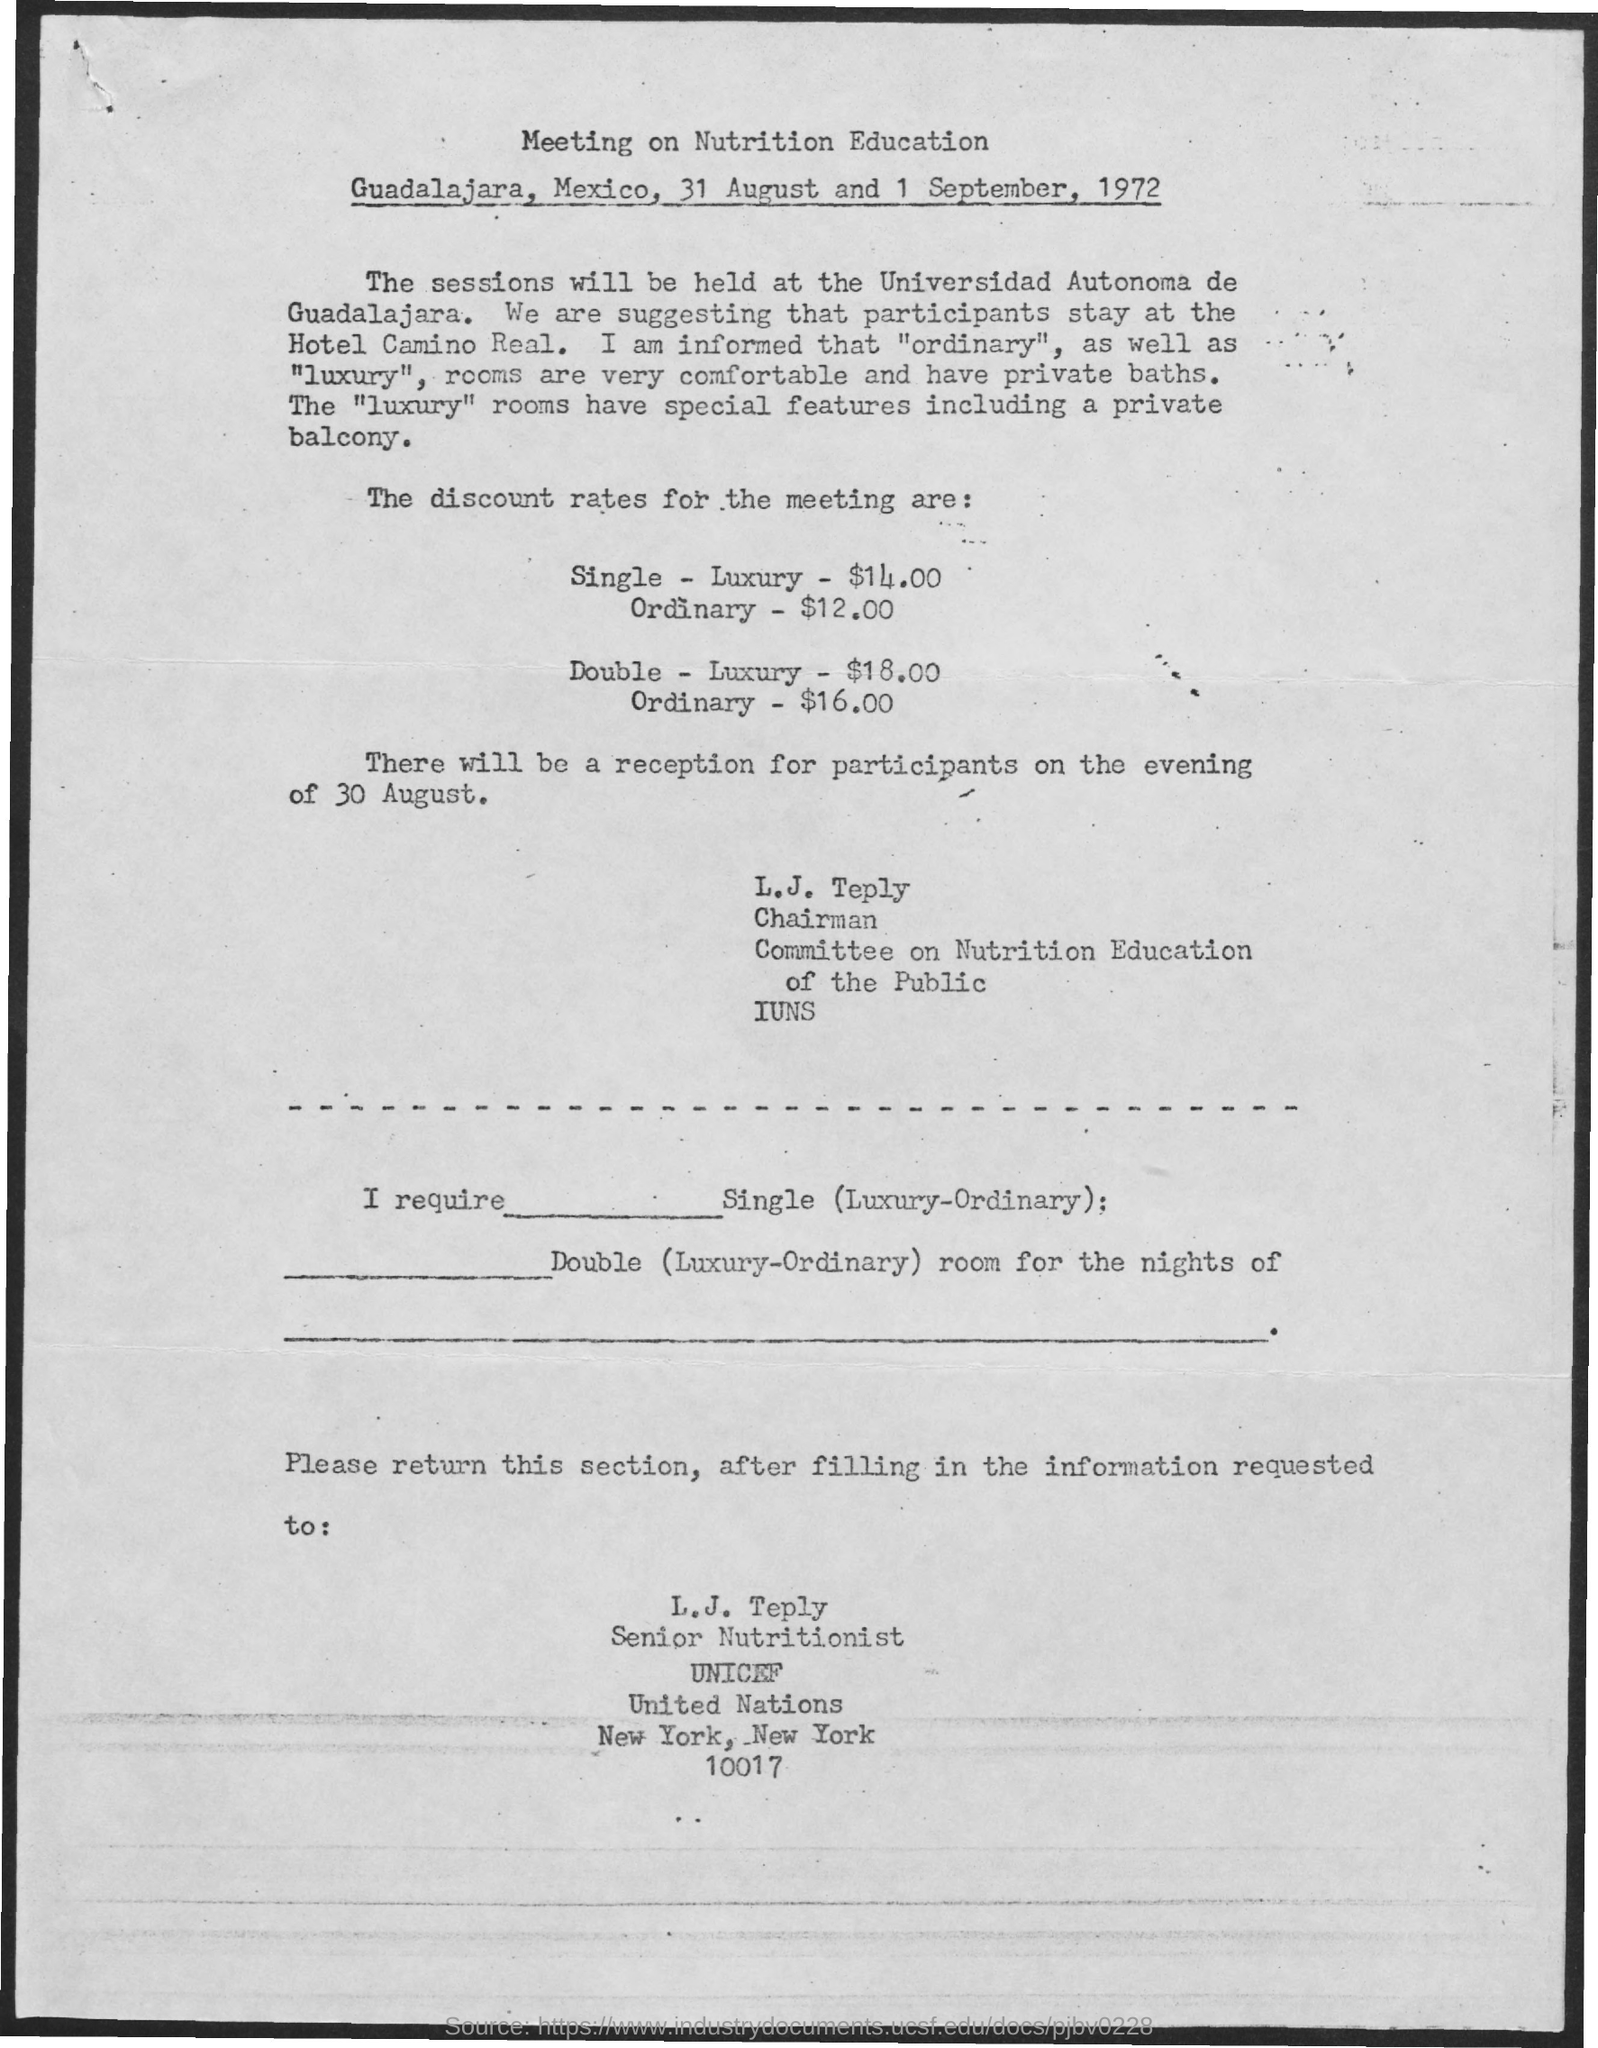When is the Meeting on Nutrition Education?
Your answer should be very brief. 31 August and 1 September, 1972. Where will the Sessions be held?
Ensure brevity in your answer.  At the universidad autonoma de guadalajara. Where are they suggesting the participants stay?
Your answer should be very brief. Hotel Camino Real. What special feature do the "luxury" rooms have?
Make the answer very short. A private balcony. What is the discount rate for the meeting for single - luxury?
Ensure brevity in your answer.  $14.00. What is the discount rate for the meeting for single - ordinary?
Your answer should be very brief. $12.00. What is the discount rate for the meeting for Double - luxury?
Your answer should be very brief. $18.00. What is the discount rate for the meeting for Double - Ordinary?
Your answer should be very brief. $16.00. When will the reception be for the participants?
Provide a succinct answer. 30 August. Who should the form be sent to?
Your answer should be compact. L. J. Teply. 